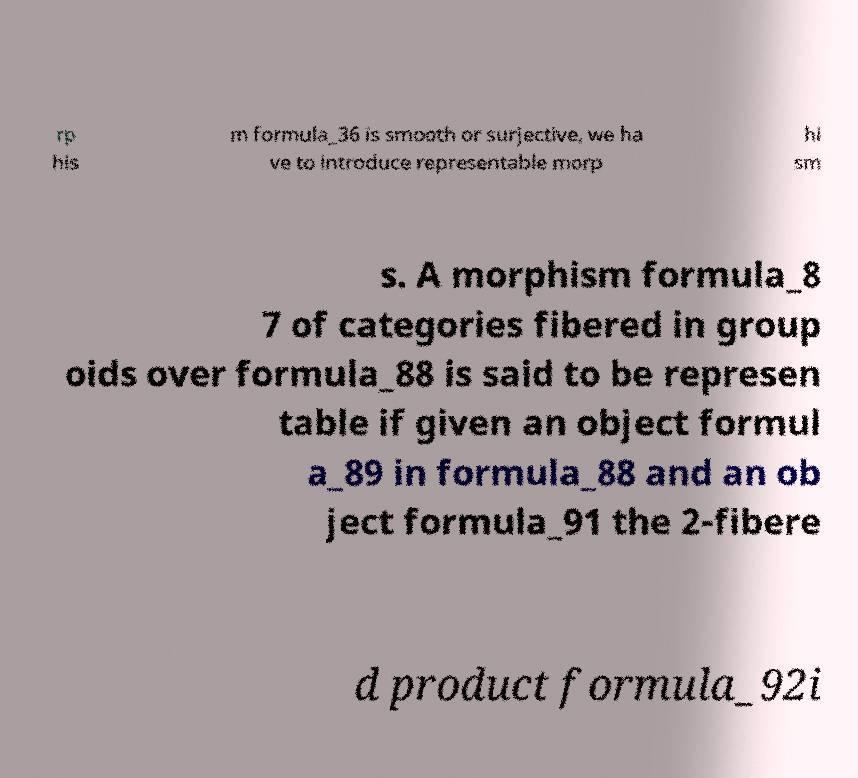Could you extract and type out the text from this image? rp his m formula_36 is smooth or surjective, we ha ve to introduce representable morp hi sm s. A morphism formula_8 7 of categories fibered in group oids over formula_88 is said to be represen table if given an object formul a_89 in formula_88 and an ob ject formula_91 the 2-fibere d product formula_92i 